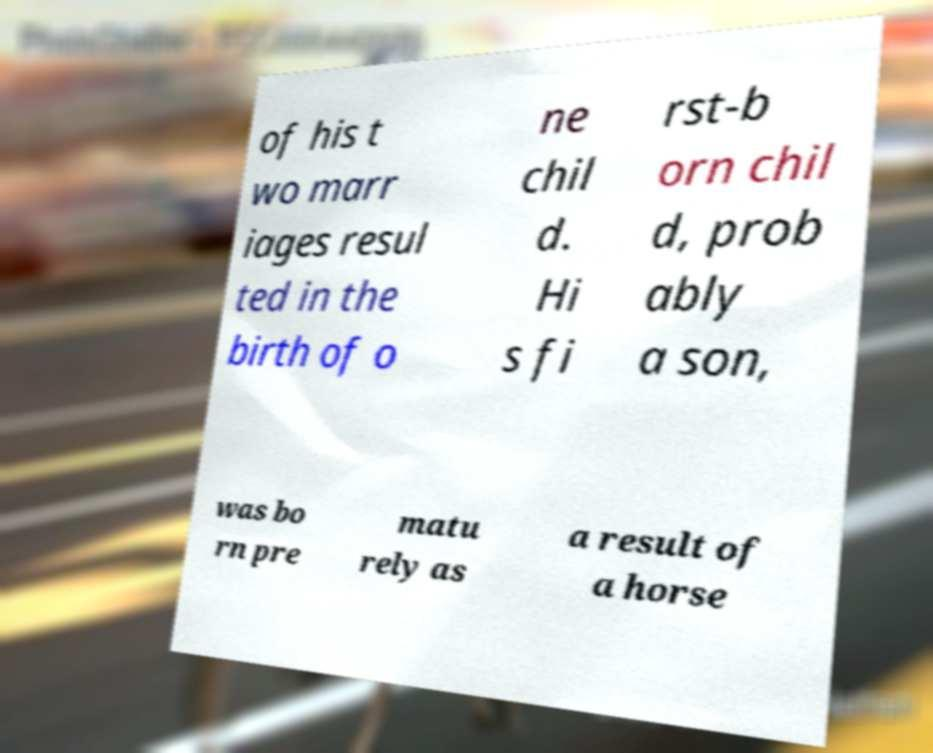What messages or text are displayed in this image? I need them in a readable, typed format. of his t wo marr iages resul ted in the birth of o ne chil d. Hi s fi rst-b orn chil d, prob ably a son, was bo rn pre matu rely as a result of a horse 